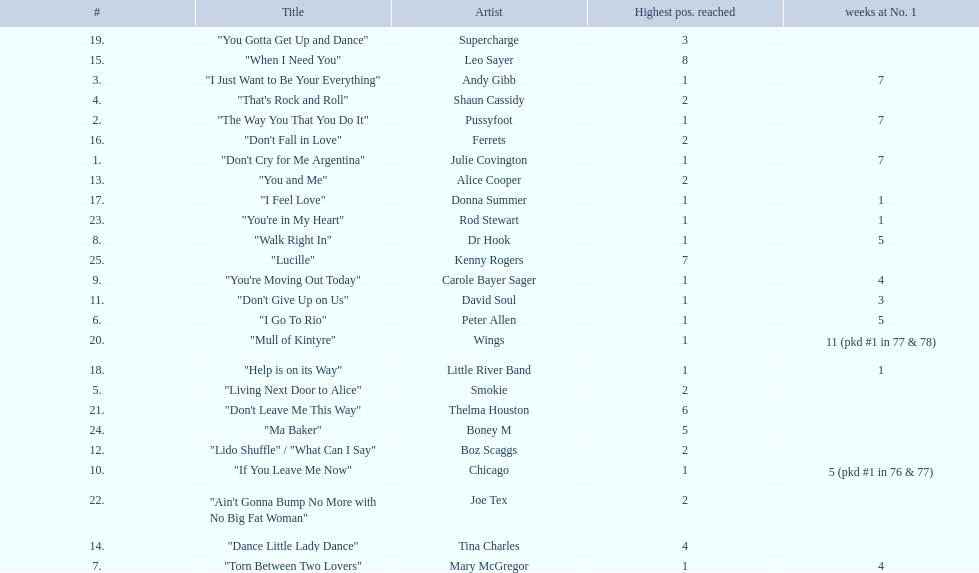How long is the longest amount of time spent at number 1? 11 (pkd #1 in 77 & 78). What song spent 11 weeks at number 1? "Mull of Kintyre". What band had a number 1 hit with this song? Wings. 